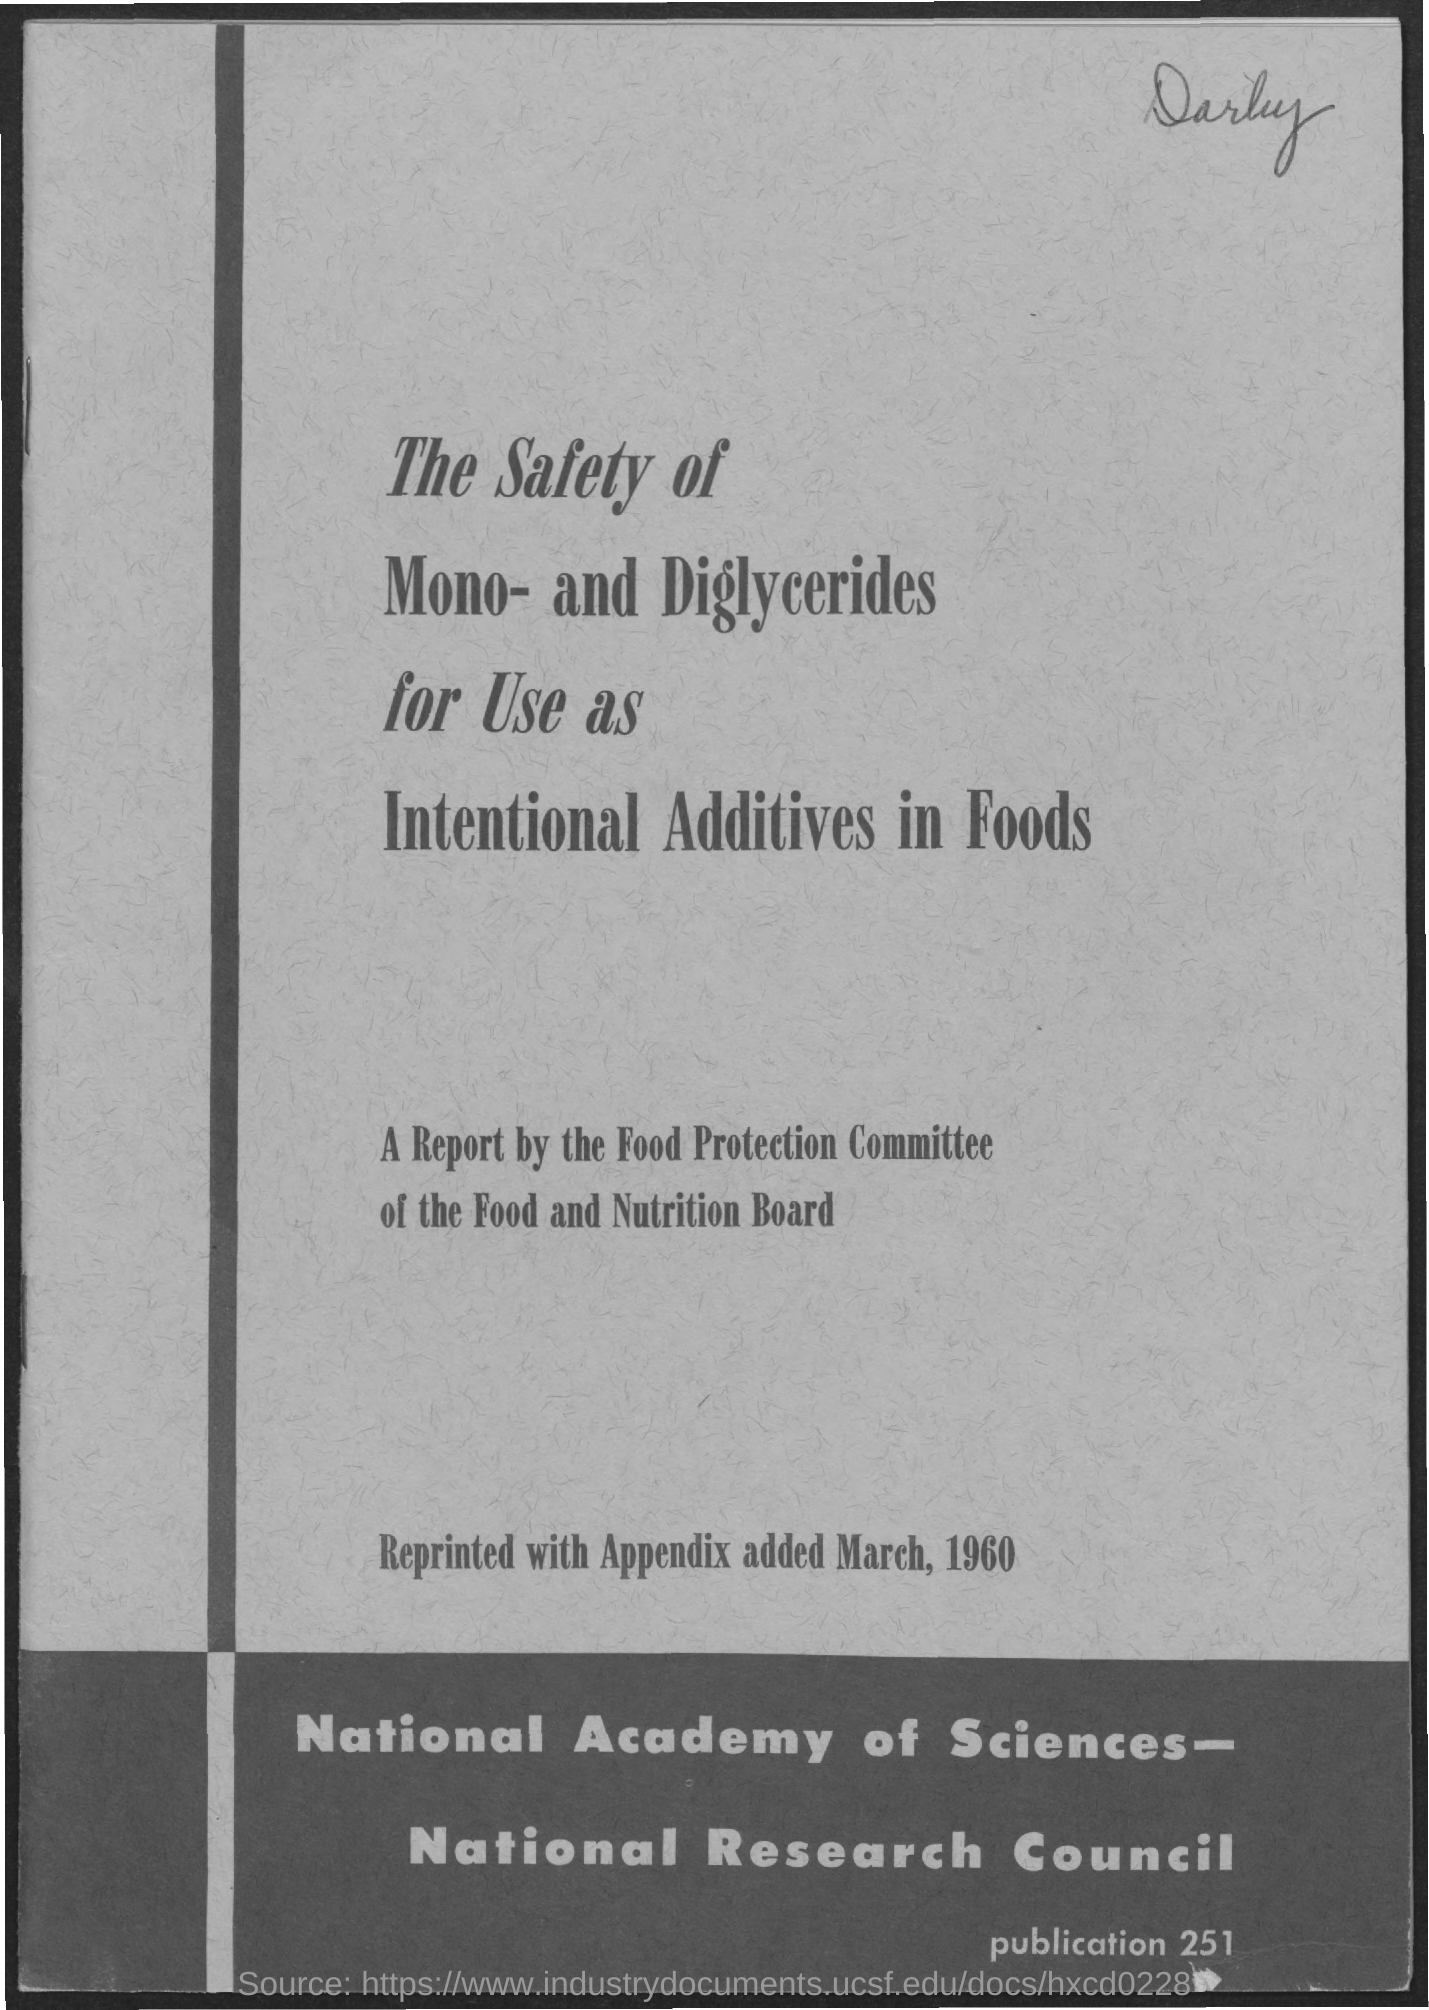The safety of what for use as intentional additives in foods?
Provide a short and direct response. Mono- and Diglycerides. When was it reprinted with appendix added?
Your answer should be very brief. March, 1960. 